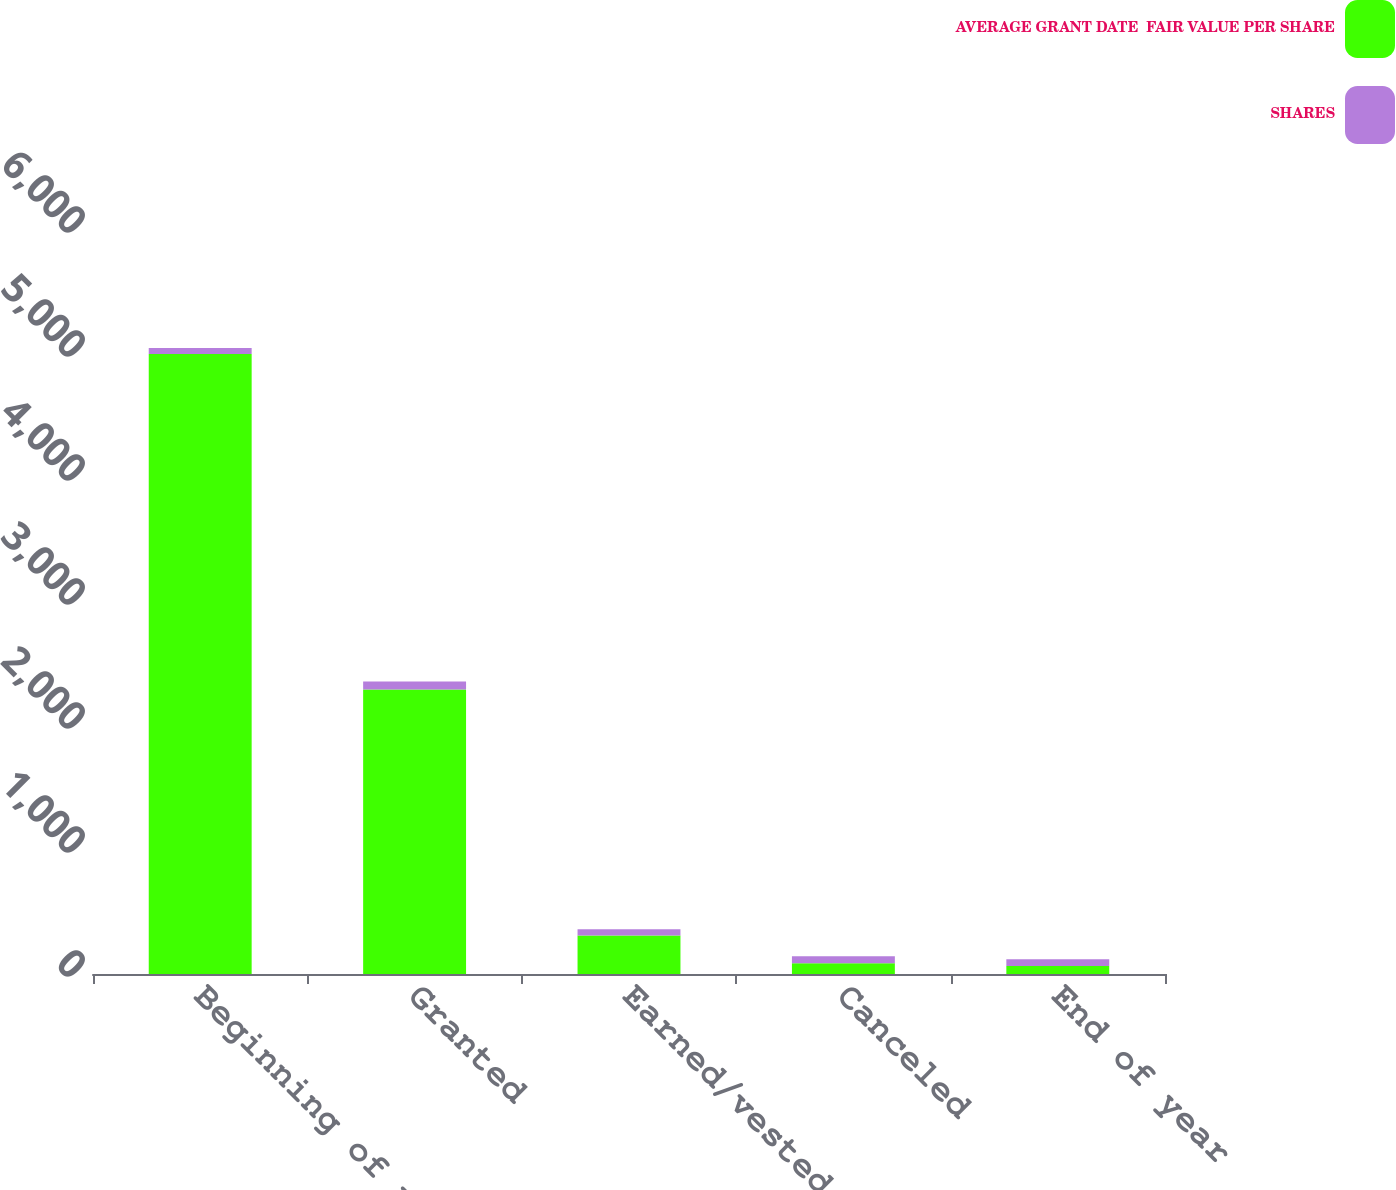Convert chart. <chart><loc_0><loc_0><loc_500><loc_500><stacked_bar_chart><ecel><fcel>Beginning of year<fcel>Granted<fcel>Earned/vested<fcel>Canceled<fcel>End of year<nl><fcel>AVERAGE GRANT DATE  FAIR VALUE PER SHARE<fcel>4999<fcel>2295<fcel>310<fcel>86<fcel>63.79<nl><fcel>SHARES<fcel>50.33<fcel>63.79<fcel>51.27<fcel>56.53<fcel>54.69<nl></chart> 